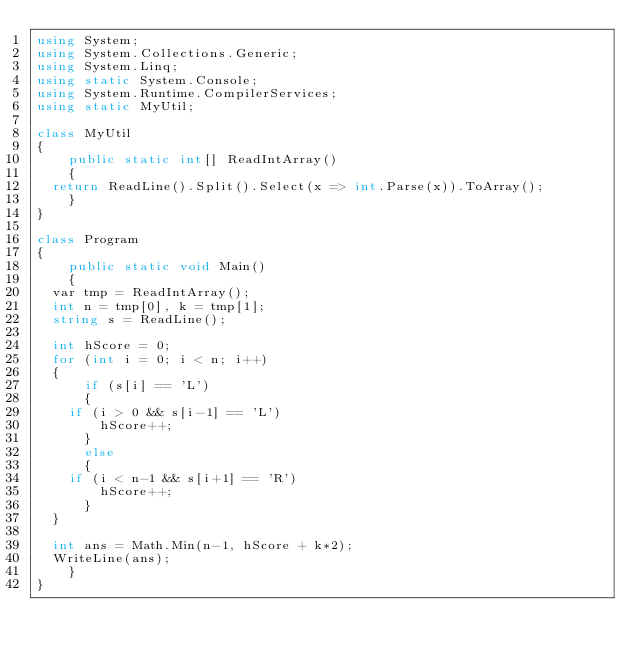<code> <loc_0><loc_0><loc_500><loc_500><_C#_>using System;
using System.Collections.Generic;
using System.Linq;
using static System.Console;
using System.Runtime.CompilerServices;
using static MyUtil;

class MyUtil
{
    public static int[] ReadIntArray()
    {
	return ReadLine().Split().Select(x => int.Parse(x)).ToArray();
    }
}

class Program
{
    public static void Main()
    {
	var tmp = ReadIntArray();
	int n = tmp[0], k = tmp[1];
	string s = ReadLine();

	int hScore = 0;
	for (int i = 0; i < n; i++)
	{
	    if (s[i] == 'L')
	    {
		if (i > 0 && s[i-1] == 'L')
		    hScore++;
	    }
	    else
	    {
		if (i < n-1 && s[i+1] == 'R')
		    hScore++;
	    }
	}

	int ans = Math.Min(n-1, hScore + k*2);
	WriteLine(ans);
    }
}
</code> 